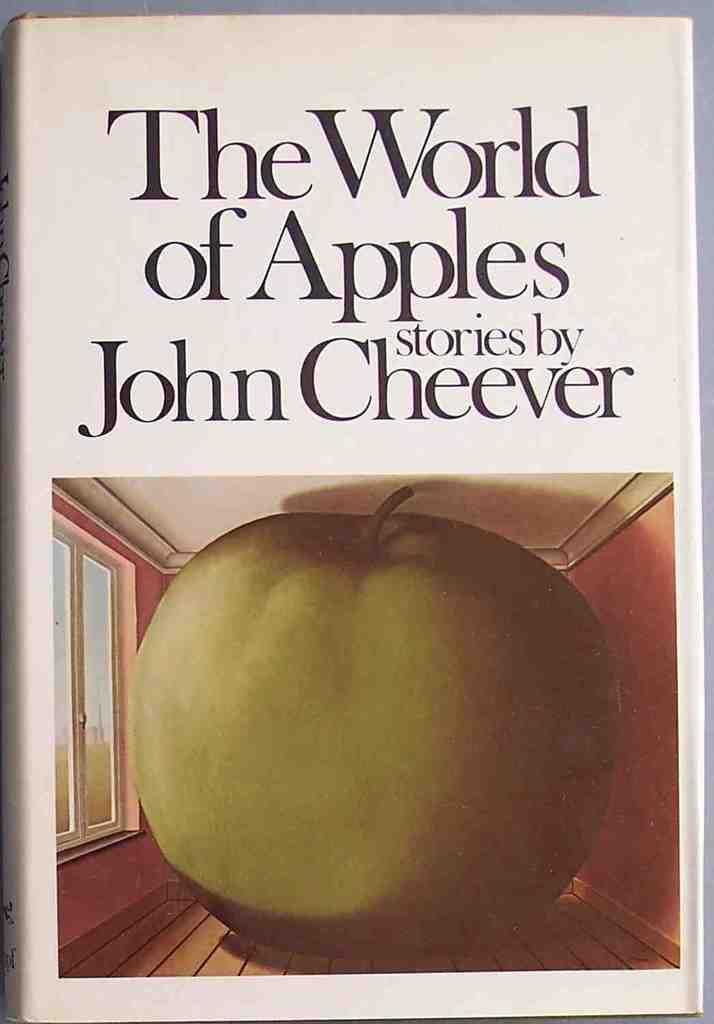What object is present in the image that is related to reading or learning? There is a book in the image. What is depicted on the cover of the book? The book has a picture of an apple on it. What type of surface is visible in the image? The image shows a floor. What type of structure is visible in the image? The image shows a wall. What feature allows natural light to enter the room in the image? There is a window visible in the image. What type of information is present on the book? There is text written on the book. Who is the creator of the beef depicted in the image? There is no beef present in the image, so it is not possible to determine who its creator might be. 